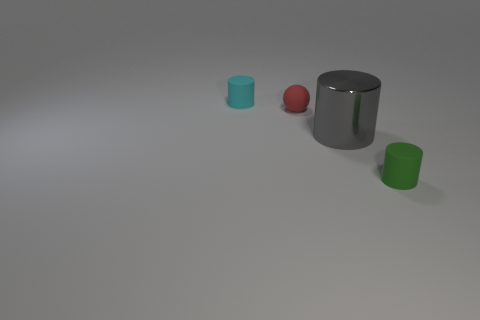Is the material of the cyan cylinder the same as the small thing that is in front of the large gray cylinder?
Make the answer very short. Yes. Does the large gray metal thing have the same shape as the red thing?
Provide a succinct answer. No. There is another tiny cyan object that is the same shape as the metal thing; what is its material?
Give a very brief answer. Rubber. There is a tiny matte object that is right of the tiny cyan object and behind the gray metallic object; what is its color?
Give a very brief answer. Red. What is the color of the matte ball?
Offer a very short reply. Red. Is there another small green thing that has the same shape as the tiny green object?
Provide a short and direct response. No. There is a matte thing that is to the right of the small red rubber thing; what is its size?
Offer a terse response. Small. What material is the cyan cylinder that is the same size as the red matte ball?
Provide a succinct answer. Rubber. Are there more small cyan matte things than blue rubber cylinders?
Keep it short and to the point. Yes. What size is the sphere that is behind the small rubber thing that is right of the ball?
Your answer should be compact. Small. 